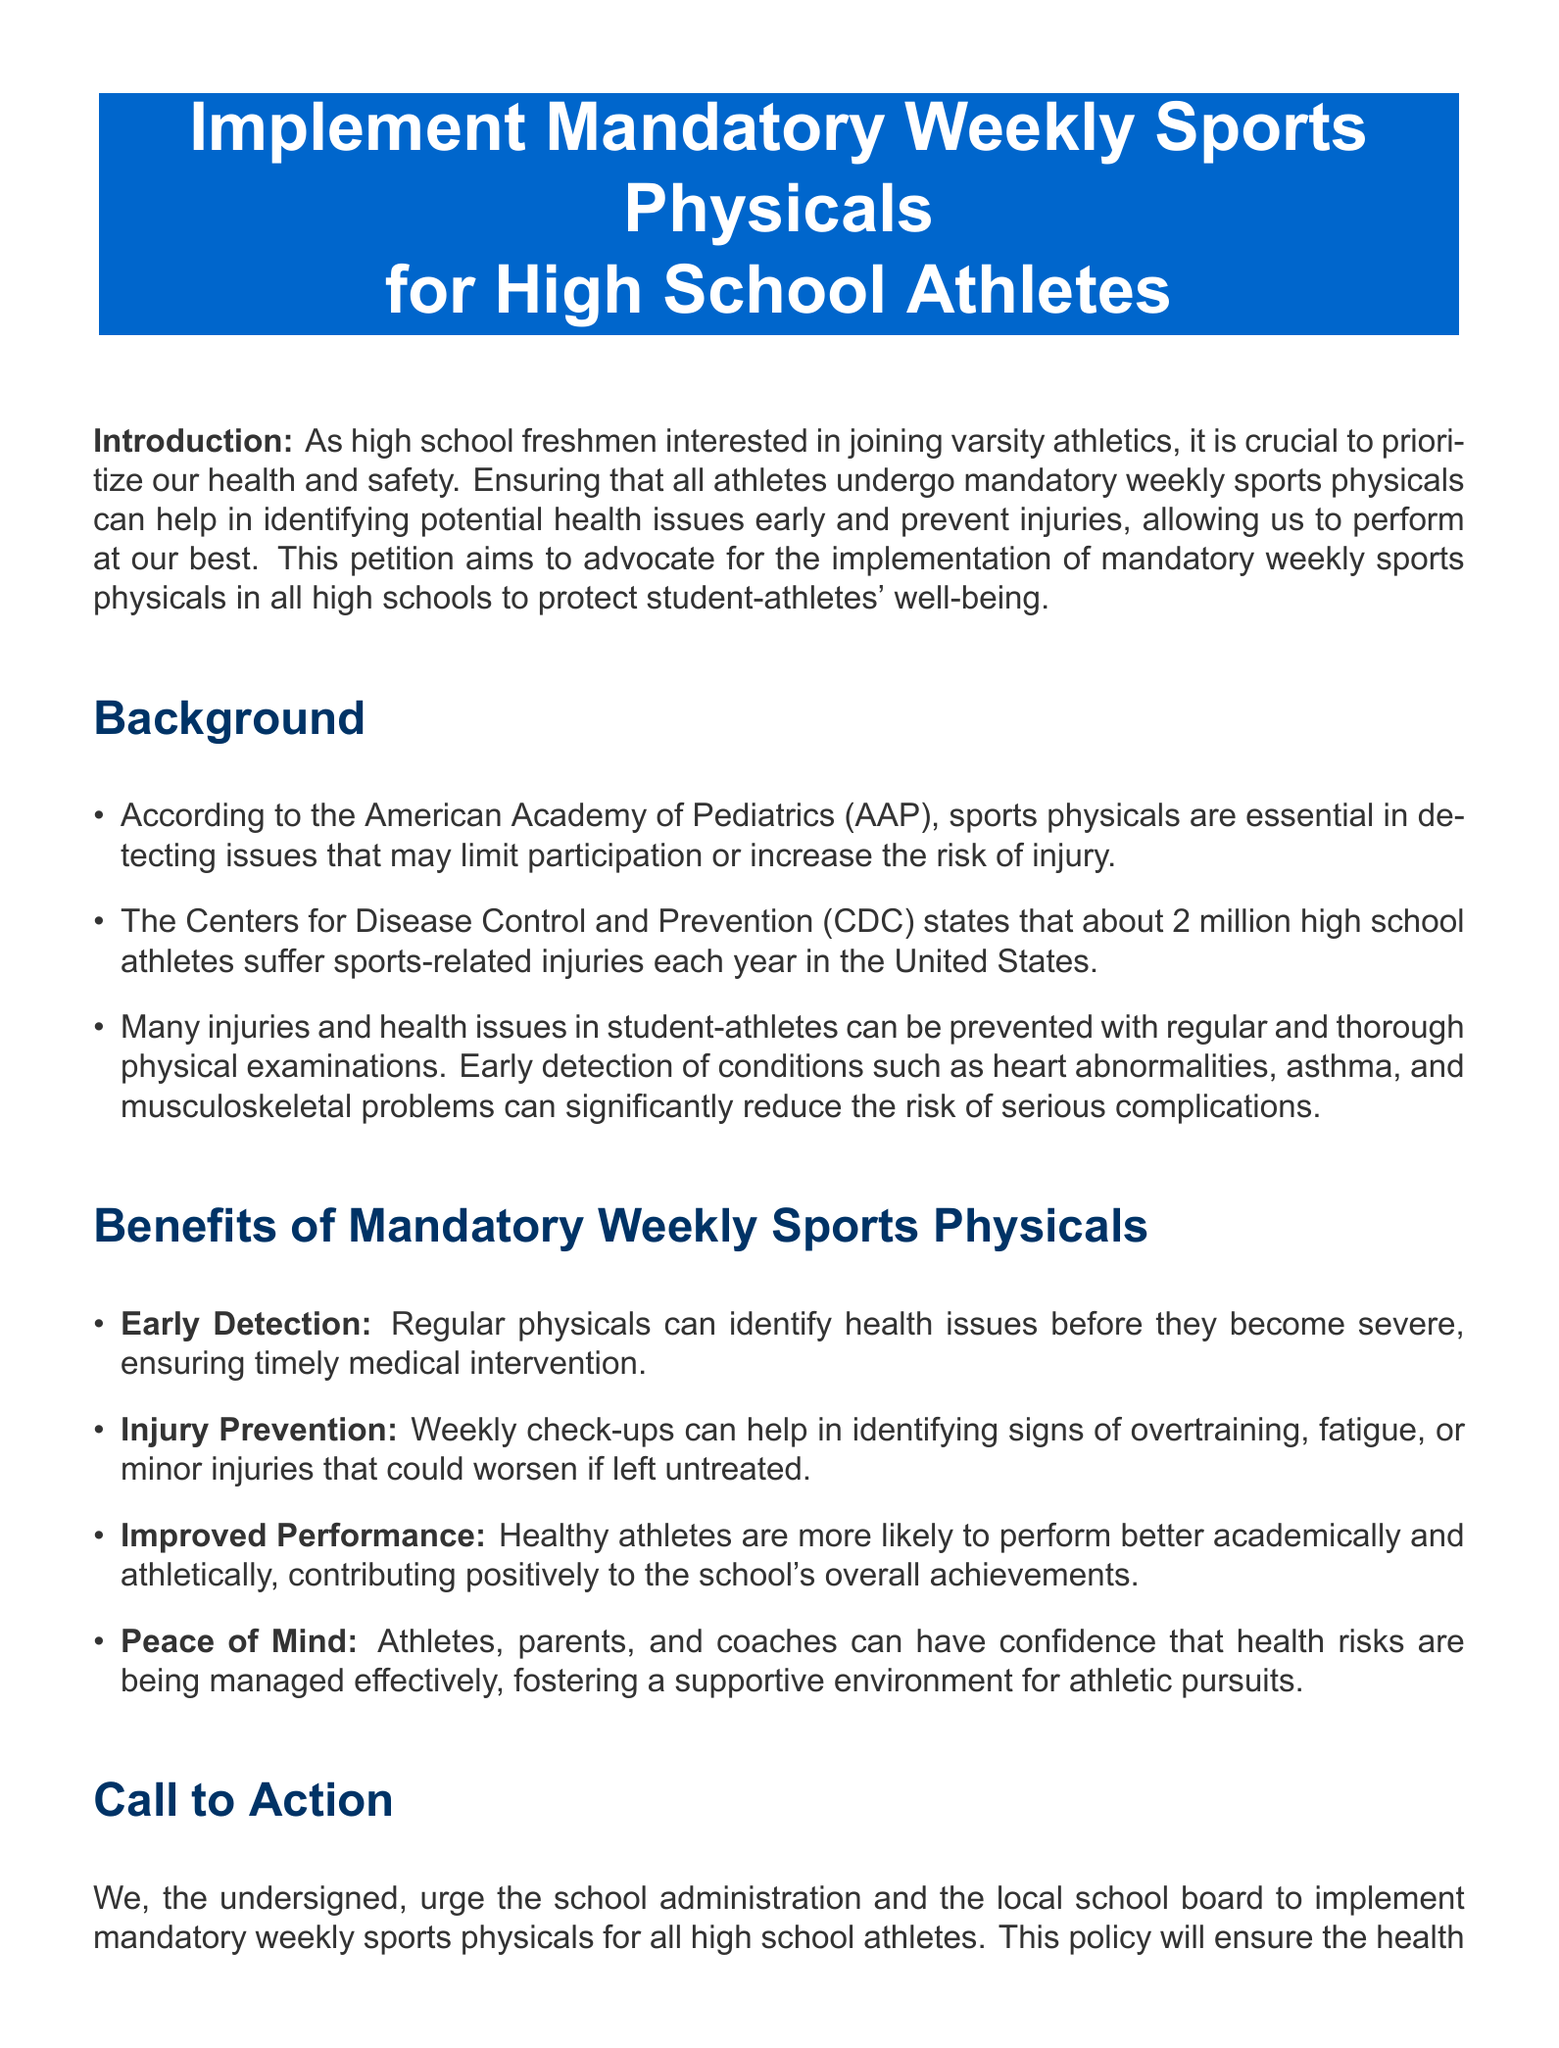What is the main purpose of this petition? The main purpose of the petition is to advocate for mandatory weekly sports physicals to protect student-athletes' well-being.
Answer: To advocate for mandatory weekly sports physicals How many high school athletes suffer injuries each year according to the CDC? The document states that about 2 million high school athletes suffer sports-related injuries each year.
Answer: 2 million What is one reason why regular physicals are essential? According to the American Academy of Pediatrics, sports physicals are essential in detecting issues that may limit participation or increase the risk of injury.
Answer: Detecting issues What are two benefits of mandatory weekly sports physicals mentioned in the document? The document lists early detection, injury prevention, improved performance, and peace of mind as benefits of mandatory weekly sports physicals.
Answer: Early detection, injury prevention Who is urged to implement the mandatory weekly sports physicals? The petition urges the school administration and the local school board to implement the policy.
Answer: School administration and local school board What is one potential serious condition that can be detected through regular physicals? The document mentions heart abnormalities, asthma, and musculoskeletal problems as possible conditions that can be detected.
Answer: Heart abnormalities What action does the petition encourage people to take? The petition encourages individuals to sign in support of the initiative for mandatory weekly sports physicals.
Answer: Sign the petition What is the color of the background for the petition's title? The document specifies that the color of the background for the title is RGB (0,102,204).
Answer: RGB (0,102,204) 